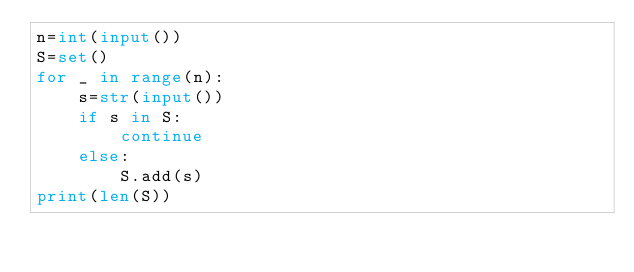Convert code to text. <code><loc_0><loc_0><loc_500><loc_500><_Python_>n=int(input())
S=set()
for _ in range(n):
    s=str(input())
    if s in S:
        continue
    else:
        S.add(s)
print(len(S))
</code> 